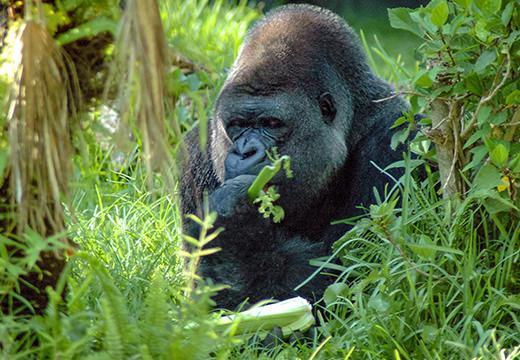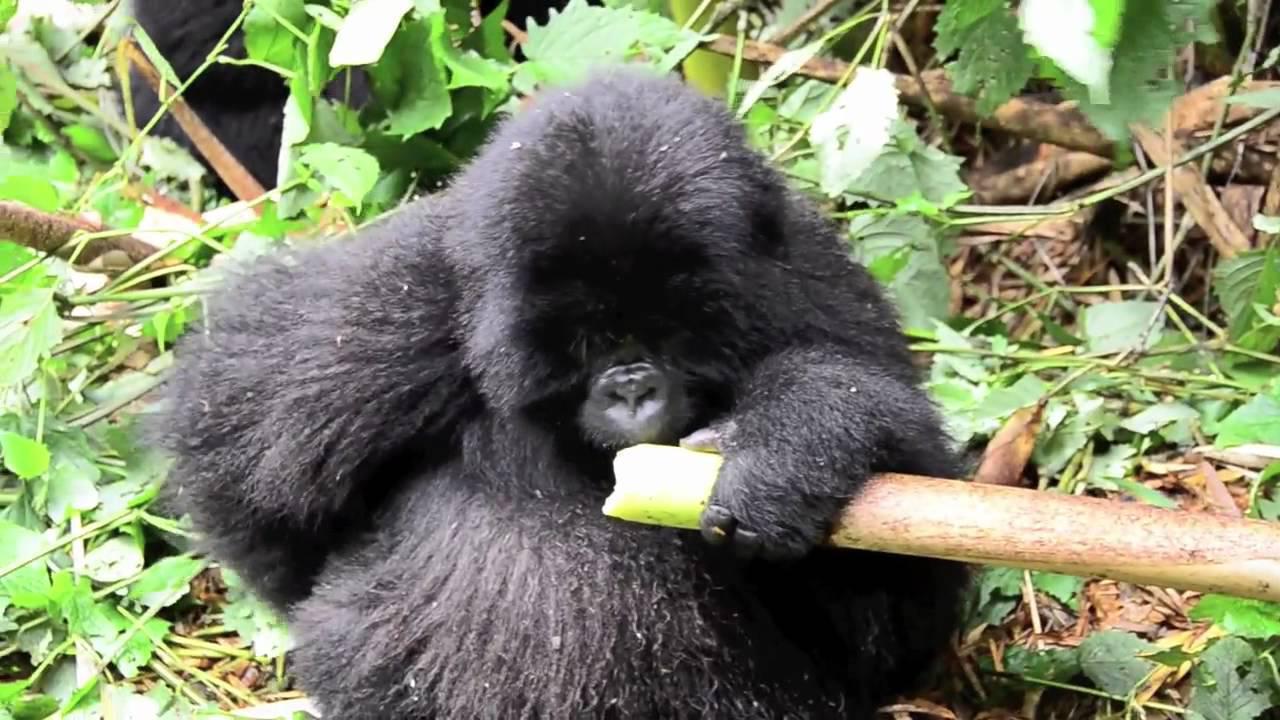The first image is the image on the left, the second image is the image on the right. Considering the images on both sides, is "The right image contains two gorillas." valid? Answer yes or no. No. The first image is the image on the left, the second image is the image on the right. For the images displayed, is the sentence "The left image features an adult male gorilla clutching a leafy green item near its mouth." factually correct? Answer yes or no. Yes. 